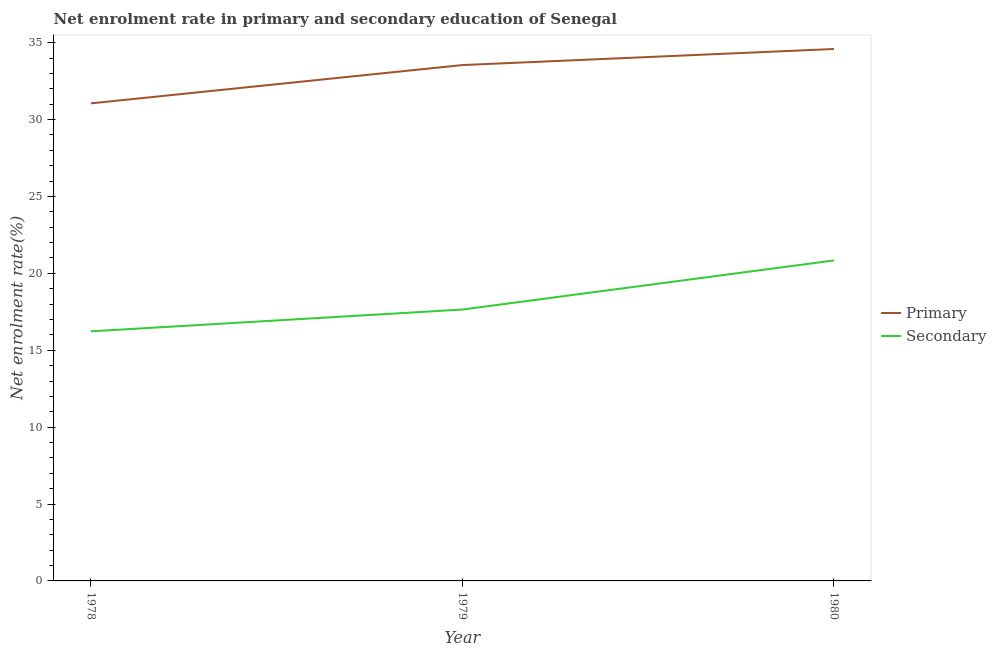How many different coloured lines are there?
Provide a short and direct response. 2. Does the line corresponding to enrollment rate in primary education intersect with the line corresponding to enrollment rate in secondary education?
Your answer should be very brief. No. Is the number of lines equal to the number of legend labels?
Your answer should be compact. Yes. What is the enrollment rate in secondary education in 1980?
Your response must be concise. 20.84. Across all years, what is the maximum enrollment rate in primary education?
Your answer should be compact. 34.59. Across all years, what is the minimum enrollment rate in primary education?
Provide a succinct answer. 31.05. In which year was the enrollment rate in secondary education maximum?
Ensure brevity in your answer.  1980. In which year was the enrollment rate in secondary education minimum?
Provide a succinct answer. 1978. What is the total enrollment rate in secondary education in the graph?
Offer a very short reply. 54.72. What is the difference between the enrollment rate in secondary education in 1978 and that in 1979?
Keep it short and to the point. -1.42. What is the difference between the enrollment rate in secondary education in 1978 and the enrollment rate in primary education in 1979?
Provide a short and direct response. -17.32. What is the average enrollment rate in secondary education per year?
Give a very brief answer. 18.24. In the year 1979, what is the difference between the enrollment rate in primary education and enrollment rate in secondary education?
Your answer should be compact. 15.9. What is the ratio of the enrollment rate in primary education in 1978 to that in 1980?
Keep it short and to the point. 0.9. What is the difference between the highest and the second highest enrollment rate in primary education?
Your response must be concise. 1.05. What is the difference between the highest and the lowest enrollment rate in primary education?
Your answer should be very brief. 3.54. Is the enrollment rate in primary education strictly greater than the enrollment rate in secondary education over the years?
Ensure brevity in your answer.  Yes. Is the enrollment rate in secondary education strictly less than the enrollment rate in primary education over the years?
Your answer should be very brief. Yes. How many lines are there?
Your response must be concise. 2. Are the values on the major ticks of Y-axis written in scientific E-notation?
Your response must be concise. No. Does the graph contain any zero values?
Provide a short and direct response. No. Where does the legend appear in the graph?
Offer a very short reply. Center right. What is the title of the graph?
Your answer should be compact. Net enrolment rate in primary and secondary education of Senegal. Does "constant 2005 US$" appear as one of the legend labels in the graph?
Offer a terse response. No. What is the label or title of the X-axis?
Make the answer very short. Year. What is the label or title of the Y-axis?
Your answer should be very brief. Net enrolment rate(%). What is the Net enrolment rate(%) of Primary in 1978?
Your answer should be compact. 31.05. What is the Net enrolment rate(%) of Secondary in 1978?
Provide a short and direct response. 16.23. What is the Net enrolment rate(%) of Primary in 1979?
Offer a very short reply. 33.55. What is the Net enrolment rate(%) of Secondary in 1979?
Your answer should be compact. 17.65. What is the Net enrolment rate(%) in Primary in 1980?
Give a very brief answer. 34.59. What is the Net enrolment rate(%) in Secondary in 1980?
Ensure brevity in your answer.  20.84. Across all years, what is the maximum Net enrolment rate(%) in Primary?
Your answer should be very brief. 34.59. Across all years, what is the maximum Net enrolment rate(%) of Secondary?
Keep it short and to the point. 20.84. Across all years, what is the minimum Net enrolment rate(%) of Primary?
Your answer should be compact. 31.05. Across all years, what is the minimum Net enrolment rate(%) of Secondary?
Provide a short and direct response. 16.23. What is the total Net enrolment rate(%) in Primary in the graph?
Ensure brevity in your answer.  99.19. What is the total Net enrolment rate(%) of Secondary in the graph?
Offer a terse response. 54.72. What is the difference between the Net enrolment rate(%) in Primary in 1978 and that in 1979?
Make the answer very short. -2.49. What is the difference between the Net enrolment rate(%) of Secondary in 1978 and that in 1979?
Offer a terse response. -1.42. What is the difference between the Net enrolment rate(%) in Primary in 1978 and that in 1980?
Your answer should be compact. -3.54. What is the difference between the Net enrolment rate(%) in Secondary in 1978 and that in 1980?
Ensure brevity in your answer.  -4.61. What is the difference between the Net enrolment rate(%) in Primary in 1979 and that in 1980?
Make the answer very short. -1.04. What is the difference between the Net enrolment rate(%) of Secondary in 1979 and that in 1980?
Offer a terse response. -3.19. What is the difference between the Net enrolment rate(%) in Primary in 1978 and the Net enrolment rate(%) in Secondary in 1979?
Your response must be concise. 13.41. What is the difference between the Net enrolment rate(%) of Primary in 1978 and the Net enrolment rate(%) of Secondary in 1980?
Ensure brevity in your answer.  10.21. What is the difference between the Net enrolment rate(%) in Primary in 1979 and the Net enrolment rate(%) in Secondary in 1980?
Keep it short and to the point. 12.71. What is the average Net enrolment rate(%) of Primary per year?
Make the answer very short. 33.06. What is the average Net enrolment rate(%) of Secondary per year?
Provide a succinct answer. 18.24. In the year 1978, what is the difference between the Net enrolment rate(%) of Primary and Net enrolment rate(%) of Secondary?
Keep it short and to the point. 14.82. In the year 1979, what is the difference between the Net enrolment rate(%) in Primary and Net enrolment rate(%) in Secondary?
Provide a short and direct response. 15.9. In the year 1980, what is the difference between the Net enrolment rate(%) of Primary and Net enrolment rate(%) of Secondary?
Your answer should be very brief. 13.75. What is the ratio of the Net enrolment rate(%) of Primary in 1978 to that in 1979?
Provide a succinct answer. 0.93. What is the ratio of the Net enrolment rate(%) of Secondary in 1978 to that in 1979?
Offer a terse response. 0.92. What is the ratio of the Net enrolment rate(%) in Primary in 1978 to that in 1980?
Give a very brief answer. 0.9. What is the ratio of the Net enrolment rate(%) of Secondary in 1978 to that in 1980?
Offer a very short reply. 0.78. What is the ratio of the Net enrolment rate(%) of Primary in 1979 to that in 1980?
Keep it short and to the point. 0.97. What is the ratio of the Net enrolment rate(%) of Secondary in 1979 to that in 1980?
Keep it short and to the point. 0.85. What is the difference between the highest and the second highest Net enrolment rate(%) in Primary?
Your answer should be compact. 1.04. What is the difference between the highest and the second highest Net enrolment rate(%) of Secondary?
Make the answer very short. 3.19. What is the difference between the highest and the lowest Net enrolment rate(%) in Primary?
Provide a short and direct response. 3.54. What is the difference between the highest and the lowest Net enrolment rate(%) in Secondary?
Ensure brevity in your answer.  4.61. 